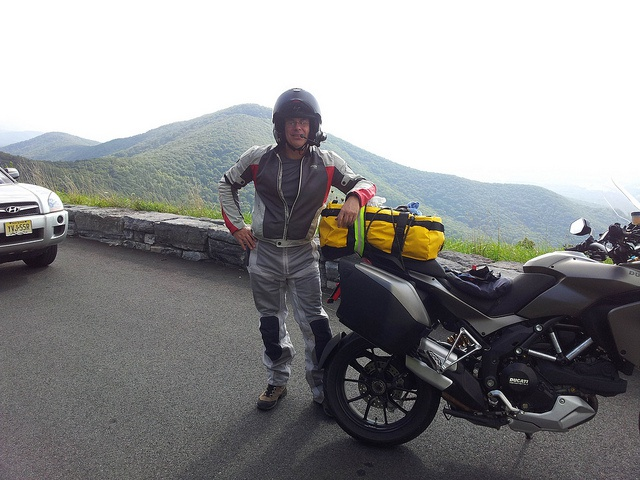Describe the objects in this image and their specific colors. I can see motorcycle in white, black, gray, and darkgray tones, people in white, black, gray, and darkgray tones, backpack in white, black, olive, and orange tones, and car in white, black, darkgray, and gray tones in this image. 